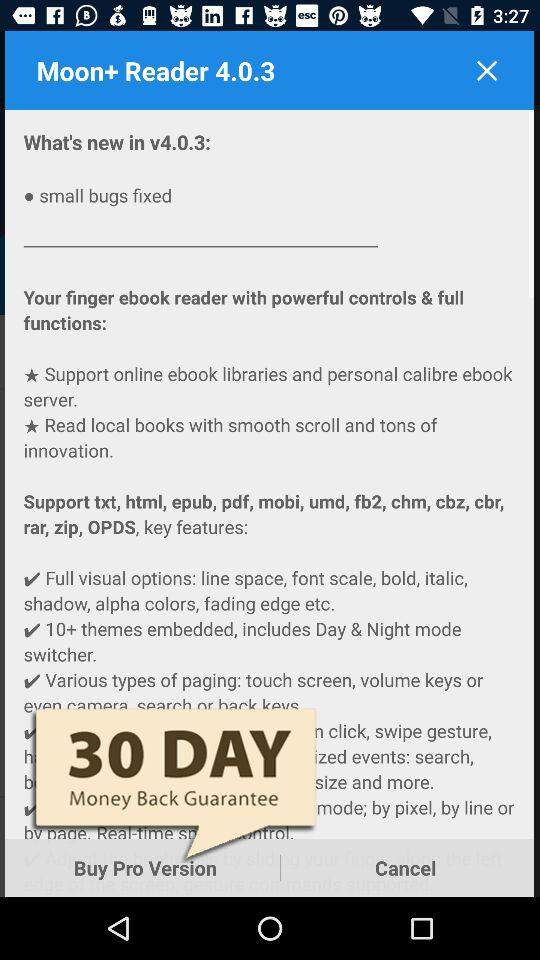How long is the money-back guarantee? The money-back guarantee is 30 days. 